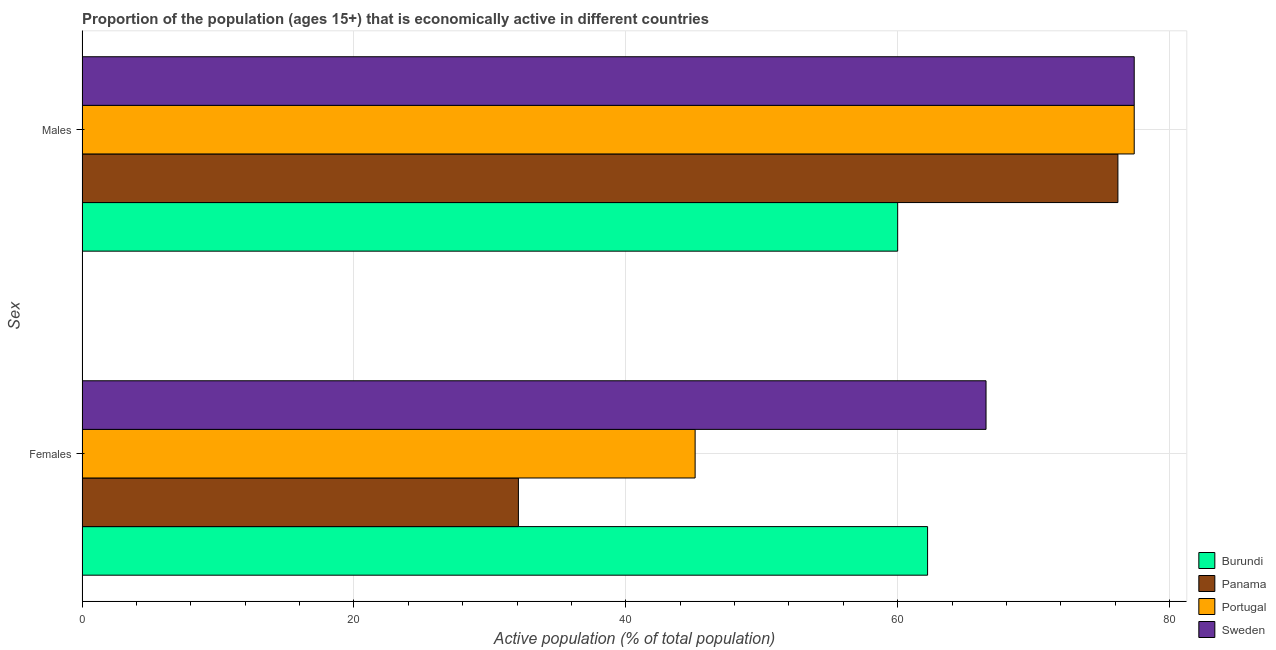How many different coloured bars are there?
Your answer should be very brief. 4. Are the number of bars per tick equal to the number of legend labels?
Offer a terse response. Yes. How many bars are there on the 1st tick from the bottom?
Offer a terse response. 4. What is the label of the 1st group of bars from the top?
Keep it short and to the point. Males. What is the percentage of economically active female population in Sweden?
Make the answer very short. 66.5. Across all countries, what is the maximum percentage of economically active male population?
Your answer should be compact. 77.4. Across all countries, what is the minimum percentage of economically active female population?
Keep it short and to the point. 32.1. In which country was the percentage of economically active female population maximum?
Offer a terse response. Sweden. In which country was the percentage of economically active male population minimum?
Ensure brevity in your answer.  Burundi. What is the total percentage of economically active female population in the graph?
Make the answer very short. 205.9. What is the difference between the percentage of economically active male population in Panama and that in Sweden?
Ensure brevity in your answer.  -1.2. What is the difference between the percentage of economically active male population in Panama and the percentage of economically active female population in Portugal?
Ensure brevity in your answer.  31.1. What is the average percentage of economically active female population per country?
Your answer should be compact. 51.47. What is the difference between the percentage of economically active male population and percentage of economically active female population in Sweden?
Ensure brevity in your answer.  10.9. What is the ratio of the percentage of economically active male population in Portugal to that in Burundi?
Offer a very short reply. 1.29. What does the 1st bar from the top in Females represents?
Your answer should be very brief. Sweden. What does the 2nd bar from the bottom in Males represents?
Your answer should be compact. Panama. How many bars are there?
Ensure brevity in your answer.  8. How many countries are there in the graph?
Keep it short and to the point. 4. Are the values on the major ticks of X-axis written in scientific E-notation?
Make the answer very short. No. Does the graph contain any zero values?
Make the answer very short. No. Does the graph contain grids?
Ensure brevity in your answer.  Yes. How many legend labels are there?
Offer a terse response. 4. How are the legend labels stacked?
Your answer should be very brief. Vertical. What is the title of the graph?
Make the answer very short. Proportion of the population (ages 15+) that is economically active in different countries. Does "Malta" appear as one of the legend labels in the graph?
Offer a terse response. No. What is the label or title of the X-axis?
Keep it short and to the point. Active population (% of total population). What is the label or title of the Y-axis?
Make the answer very short. Sex. What is the Active population (% of total population) of Burundi in Females?
Provide a succinct answer. 62.2. What is the Active population (% of total population) of Panama in Females?
Provide a succinct answer. 32.1. What is the Active population (% of total population) in Portugal in Females?
Provide a succinct answer. 45.1. What is the Active population (% of total population) of Sweden in Females?
Ensure brevity in your answer.  66.5. What is the Active population (% of total population) of Burundi in Males?
Make the answer very short. 60. What is the Active population (% of total population) in Panama in Males?
Your response must be concise. 76.2. What is the Active population (% of total population) in Portugal in Males?
Your response must be concise. 77.4. What is the Active population (% of total population) in Sweden in Males?
Ensure brevity in your answer.  77.4. Across all Sex, what is the maximum Active population (% of total population) of Burundi?
Ensure brevity in your answer.  62.2. Across all Sex, what is the maximum Active population (% of total population) of Panama?
Provide a short and direct response. 76.2. Across all Sex, what is the maximum Active population (% of total population) in Portugal?
Make the answer very short. 77.4. Across all Sex, what is the maximum Active population (% of total population) in Sweden?
Your answer should be compact. 77.4. Across all Sex, what is the minimum Active population (% of total population) in Panama?
Ensure brevity in your answer.  32.1. Across all Sex, what is the minimum Active population (% of total population) of Portugal?
Give a very brief answer. 45.1. Across all Sex, what is the minimum Active population (% of total population) of Sweden?
Ensure brevity in your answer.  66.5. What is the total Active population (% of total population) in Burundi in the graph?
Give a very brief answer. 122.2. What is the total Active population (% of total population) of Panama in the graph?
Make the answer very short. 108.3. What is the total Active population (% of total population) of Portugal in the graph?
Keep it short and to the point. 122.5. What is the total Active population (% of total population) of Sweden in the graph?
Provide a short and direct response. 143.9. What is the difference between the Active population (% of total population) of Panama in Females and that in Males?
Provide a short and direct response. -44.1. What is the difference between the Active population (% of total population) of Portugal in Females and that in Males?
Provide a succinct answer. -32.3. What is the difference between the Active population (% of total population) of Burundi in Females and the Active population (% of total population) of Portugal in Males?
Make the answer very short. -15.2. What is the difference between the Active population (% of total population) in Burundi in Females and the Active population (% of total population) in Sweden in Males?
Offer a terse response. -15.2. What is the difference between the Active population (% of total population) in Panama in Females and the Active population (% of total population) in Portugal in Males?
Ensure brevity in your answer.  -45.3. What is the difference between the Active population (% of total population) in Panama in Females and the Active population (% of total population) in Sweden in Males?
Offer a terse response. -45.3. What is the difference between the Active population (% of total population) in Portugal in Females and the Active population (% of total population) in Sweden in Males?
Make the answer very short. -32.3. What is the average Active population (% of total population) of Burundi per Sex?
Provide a succinct answer. 61.1. What is the average Active population (% of total population) of Panama per Sex?
Provide a short and direct response. 54.15. What is the average Active population (% of total population) in Portugal per Sex?
Provide a succinct answer. 61.25. What is the average Active population (% of total population) of Sweden per Sex?
Provide a succinct answer. 71.95. What is the difference between the Active population (% of total population) in Burundi and Active population (% of total population) in Panama in Females?
Make the answer very short. 30.1. What is the difference between the Active population (% of total population) in Burundi and Active population (% of total population) in Sweden in Females?
Keep it short and to the point. -4.3. What is the difference between the Active population (% of total population) of Panama and Active population (% of total population) of Portugal in Females?
Provide a succinct answer. -13. What is the difference between the Active population (% of total population) in Panama and Active population (% of total population) in Sweden in Females?
Give a very brief answer. -34.4. What is the difference between the Active population (% of total population) in Portugal and Active population (% of total population) in Sweden in Females?
Give a very brief answer. -21.4. What is the difference between the Active population (% of total population) in Burundi and Active population (% of total population) in Panama in Males?
Provide a short and direct response. -16.2. What is the difference between the Active population (% of total population) of Burundi and Active population (% of total population) of Portugal in Males?
Ensure brevity in your answer.  -17.4. What is the difference between the Active population (% of total population) in Burundi and Active population (% of total population) in Sweden in Males?
Make the answer very short. -17.4. What is the difference between the Active population (% of total population) of Panama and Active population (% of total population) of Portugal in Males?
Give a very brief answer. -1.2. What is the difference between the Active population (% of total population) in Portugal and Active population (% of total population) in Sweden in Males?
Provide a succinct answer. 0. What is the ratio of the Active population (% of total population) in Burundi in Females to that in Males?
Ensure brevity in your answer.  1.04. What is the ratio of the Active population (% of total population) of Panama in Females to that in Males?
Provide a succinct answer. 0.42. What is the ratio of the Active population (% of total population) of Portugal in Females to that in Males?
Provide a succinct answer. 0.58. What is the ratio of the Active population (% of total population) of Sweden in Females to that in Males?
Offer a terse response. 0.86. What is the difference between the highest and the second highest Active population (% of total population) of Burundi?
Offer a terse response. 2.2. What is the difference between the highest and the second highest Active population (% of total population) in Panama?
Provide a short and direct response. 44.1. What is the difference between the highest and the second highest Active population (% of total population) of Portugal?
Give a very brief answer. 32.3. What is the difference between the highest and the second highest Active population (% of total population) of Sweden?
Your response must be concise. 10.9. What is the difference between the highest and the lowest Active population (% of total population) in Burundi?
Offer a very short reply. 2.2. What is the difference between the highest and the lowest Active population (% of total population) in Panama?
Offer a terse response. 44.1. What is the difference between the highest and the lowest Active population (% of total population) of Portugal?
Your answer should be compact. 32.3. What is the difference between the highest and the lowest Active population (% of total population) in Sweden?
Your answer should be compact. 10.9. 